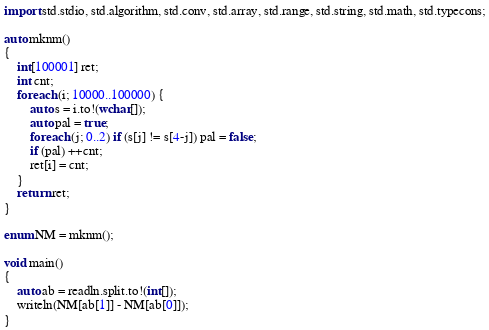Convert code to text. <code><loc_0><loc_0><loc_500><loc_500><_D_>import std.stdio, std.algorithm, std.conv, std.array, std.range, std.string, std.math, std.typecons;

auto mknm()
{
    int[100001] ret;
    int cnt;
    foreach (i; 10000..100000) {
        auto s = i.to!(wchar[]);
        auto pal = true;
        foreach (j; 0..2) if (s[j] != s[4-j]) pal = false;
        if (pal) ++cnt;
        ret[i] = cnt;
    }
    return ret;
}

enum NM = mknm();

void main()
{
    auto ab = readln.split.to!(int[]);
    writeln(NM[ab[1]] - NM[ab[0]]);
}</code> 